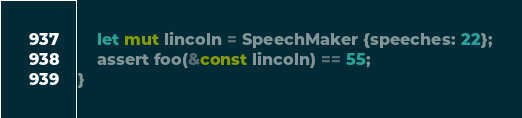<code> <loc_0><loc_0><loc_500><loc_500><_Rust_>    let mut lincoln = SpeechMaker {speeches: 22};
    assert foo(&const lincoln) == 55;
}
</code> 